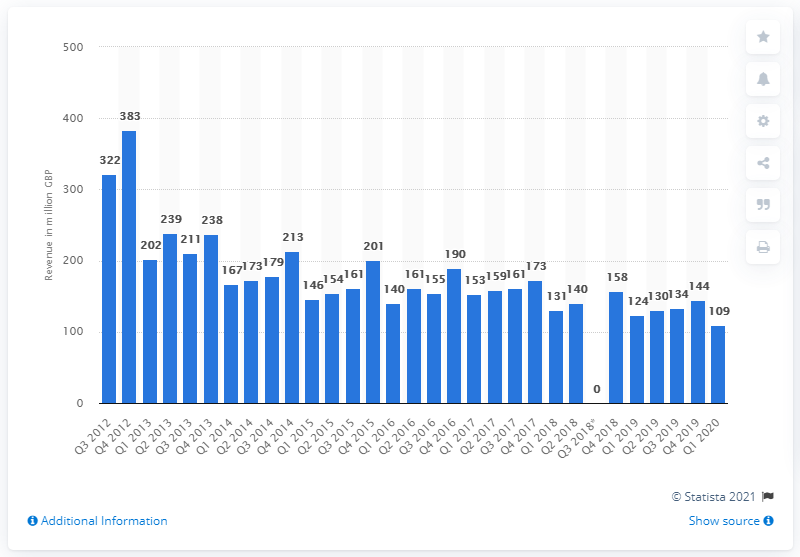Outline some significant characteristics in this image. The revenue of photo equipment in the first quarter of 2020 was 109.. In 2013, the total revenue generated from photo equipment sales was 238... 